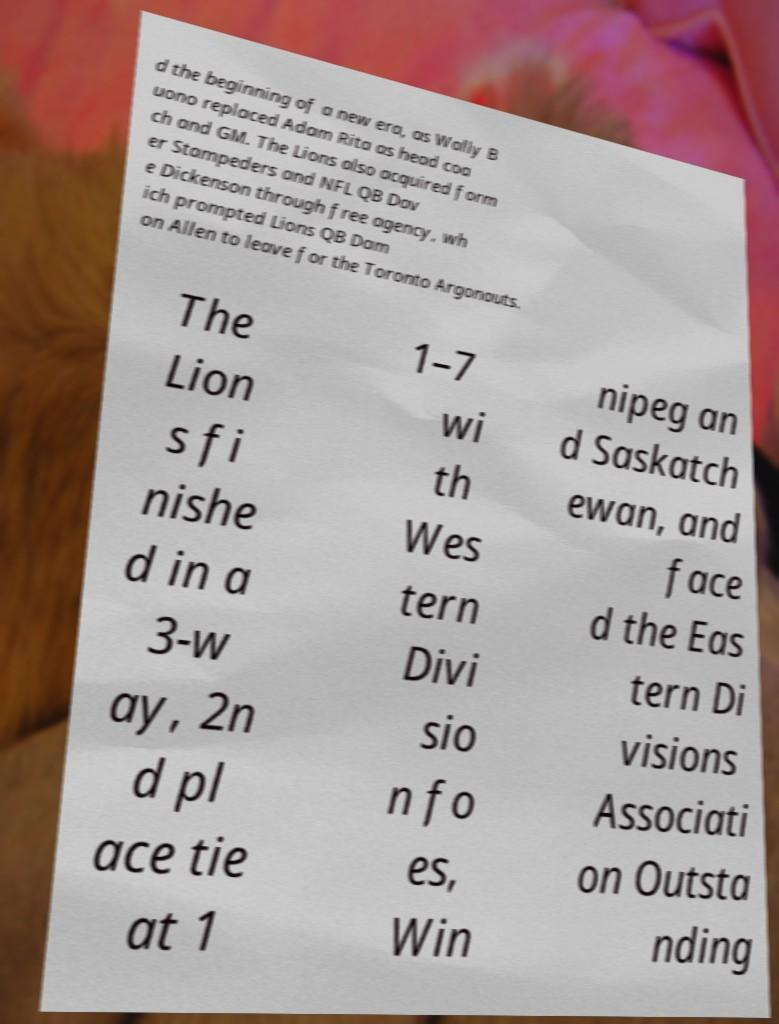For documentation purposes, I need the text within this image transcribed. Could you provide that? d the beginning of a new era, as Wally B uono replaced Adam Rita as head coa ch and GM. The Lions also acquired form er Stampeders and NFL QB Dav e Dickenson through free agency, wh ich prompted Lions QB Dam on Allen to leave for the Toronto Argonauts. The Lion s fi nishe d in a 3-w ay, 2n d pl ace tie at 1 1–7 wi th Wes tern Divi sio n fo es, Win nipeg an d Saskatch ewan, and face d the Eas tern Di visions Associati on Outsta nding 